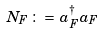<formula> <loc_0><loc_0><loc_500><loc_500>N _ { F } \, \colon = \, a _ { F } ^ { \dag } a _ { F }</formula> 